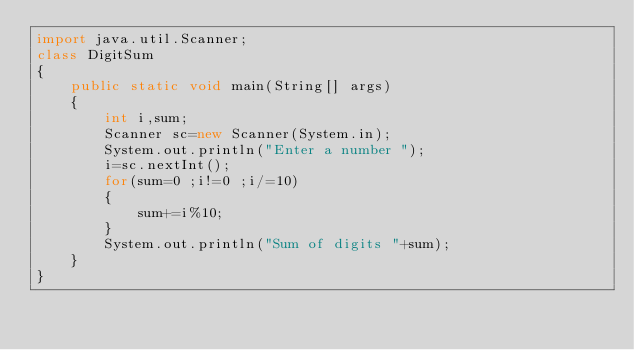<code> <loc_0><loc_0><loc_500><loc_500><_Java_>import java.util.Scanner;
class DigitSum
{
    public static void main(String[] args)
    {
        int i,sum;
        Scanner sc=new Scanner(System.in);
        System.out.println("Enter a number ");
        i=sc.nextInt();
        for(sum=0 ;i!=0 ;i/=10)
        {
            sum+=i%10;
        }
        System.out.println("Sum of digits "+sum);
    }
}
</code> 